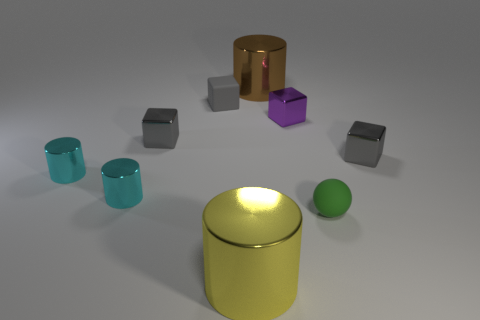What number of shiny objects are there?
Keep it short and to the point. 7. How many metal objects are either brown objects or large objects?
Offer a very short reply. 2. What number of big shiny cylinders are the same color as the small sphere?
Give a very brief answer. 0. What is the material of the large object in front of the tiny rubber object that is in front of the purple thing?
Offer a terse response. Metal. How big is the purple object?
Keep it short and to the point. Small. What number of purple metallic things have the same size as the matte cube?
Make the answer very short. 1. How many large brown shiny objects are the same shape as the gray matte object?
Offer a very short reply. 0. Are there an equal number of gray rubber objects behind the large yellow thing and tiny red cylinders?
Make the answer very short. No. Is there any other thing that has the same size as the brown cylinder?
Offer a very short reply. Yes. There is another rubber object that is the same size as the green rubber object; what is its shape?
Your answer should be compact. Cube. 